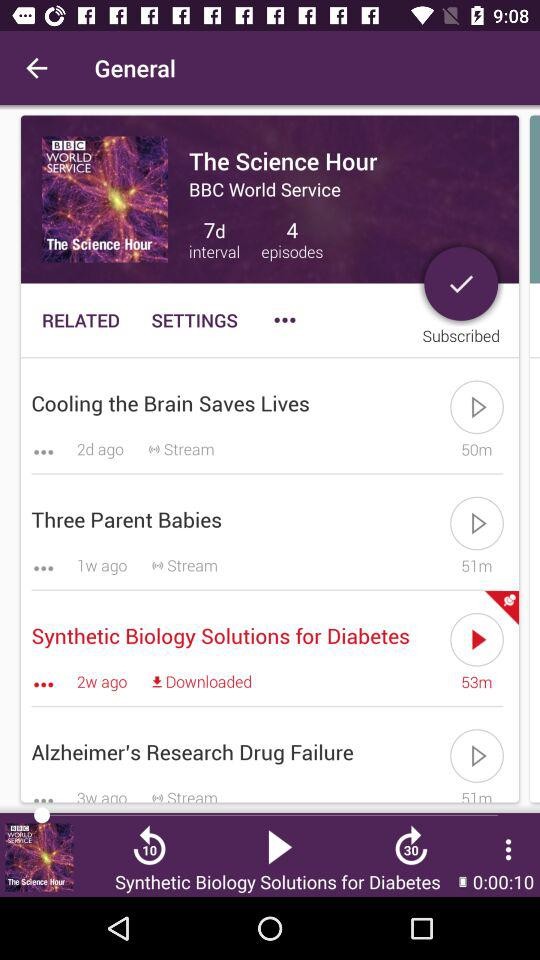What is the show's name? The show's name is "The Science Hour". 